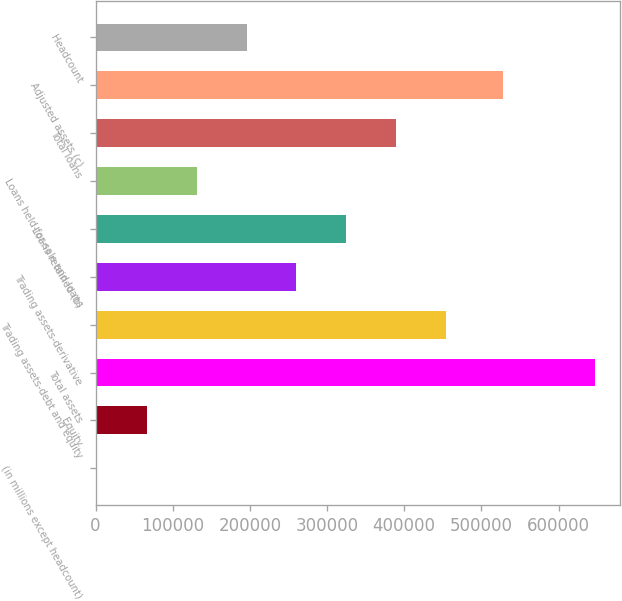Convert chart to OTSL. <chart><loc_0><loc_0><loc_500><loc_500><bar_chart><fcel>(in millions except headcount)<fcel>Equity<fcel>Total assets<fcel>Trading assets-debt and equity<fcel>Trading assets-derivative<fcel>Loans retained (b)<fcel>Loans held-for-sale and loans<fcel>Total loans<fcel>Adjusted assets (c)<fcel>Headcount<nl><fcel>2006<fcel>66562.3<fcel>647569<fcel>453900<fcel>260231<fcel>324788<fcel>131119<fcel>389344<fcel>527753<fcel>195675<nl></chart> 